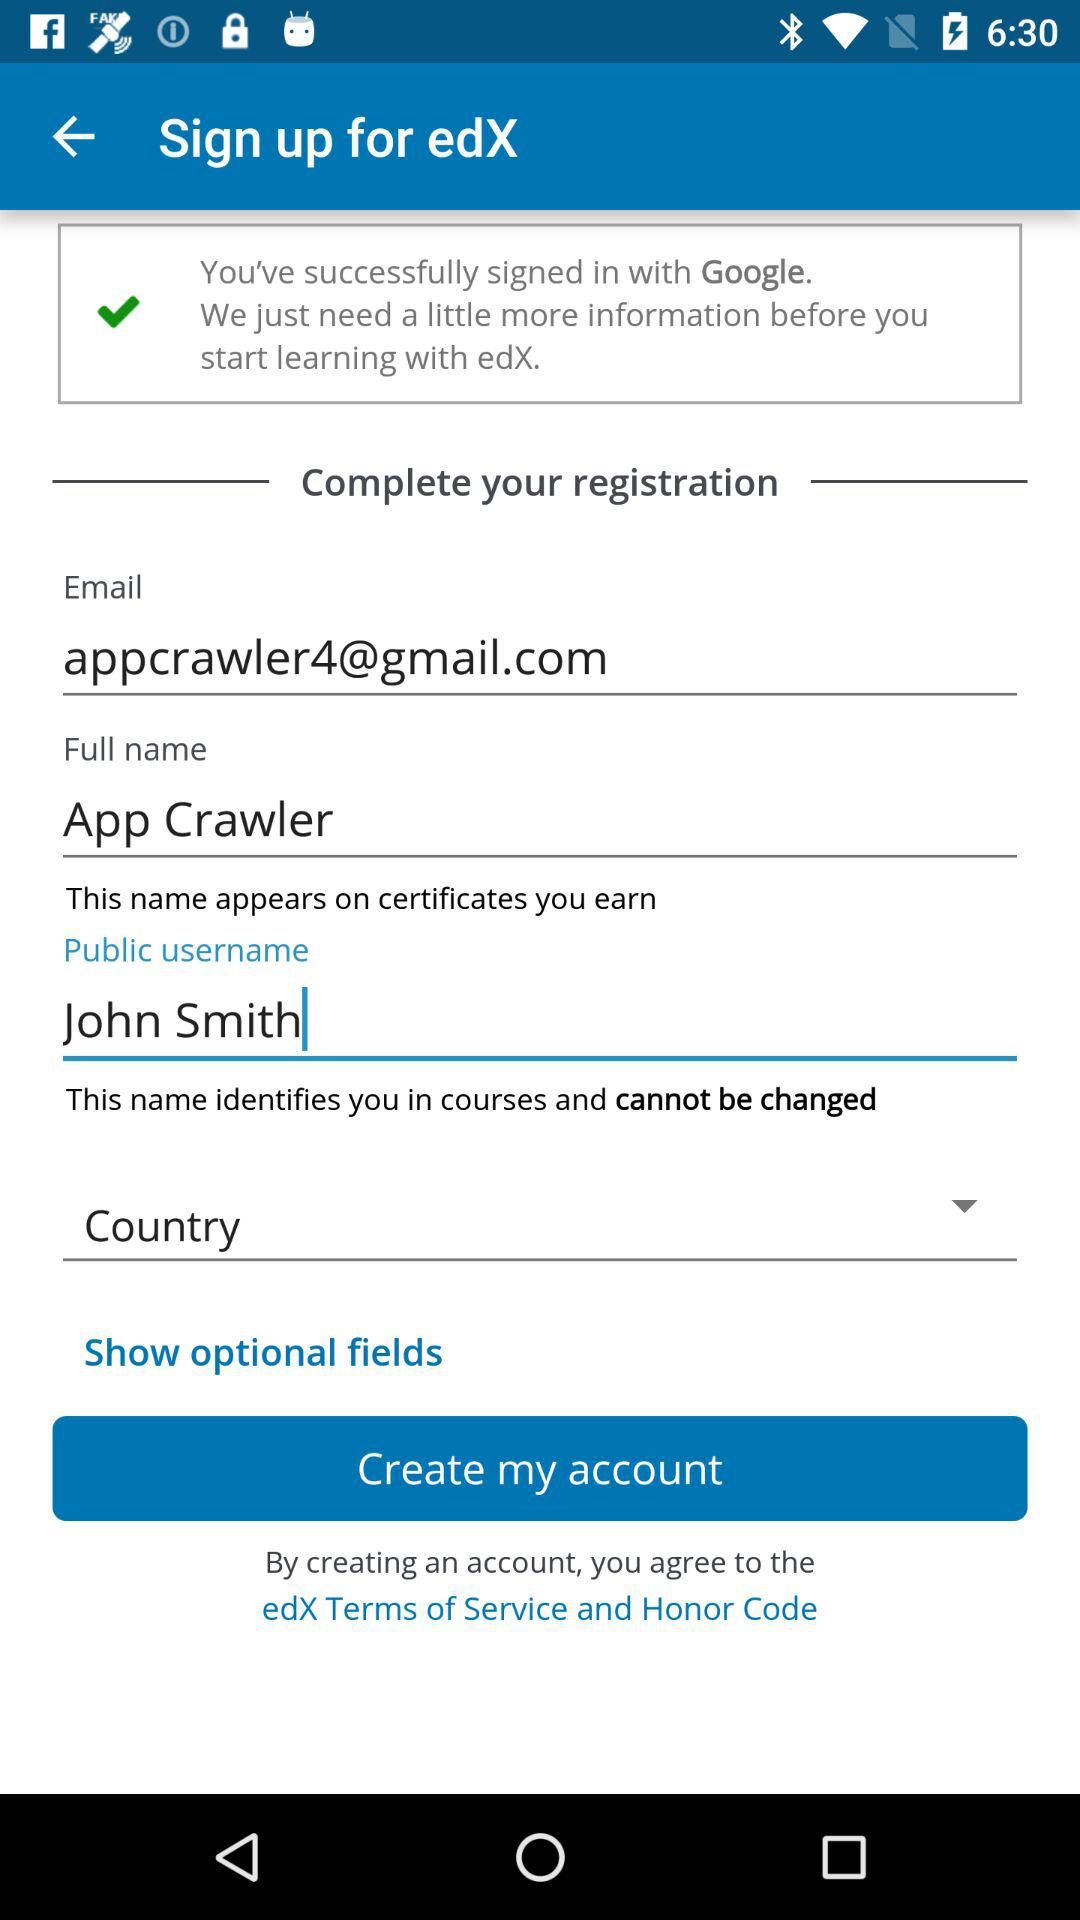What is the email address? The email address is appcrawler4@gmail.com. 